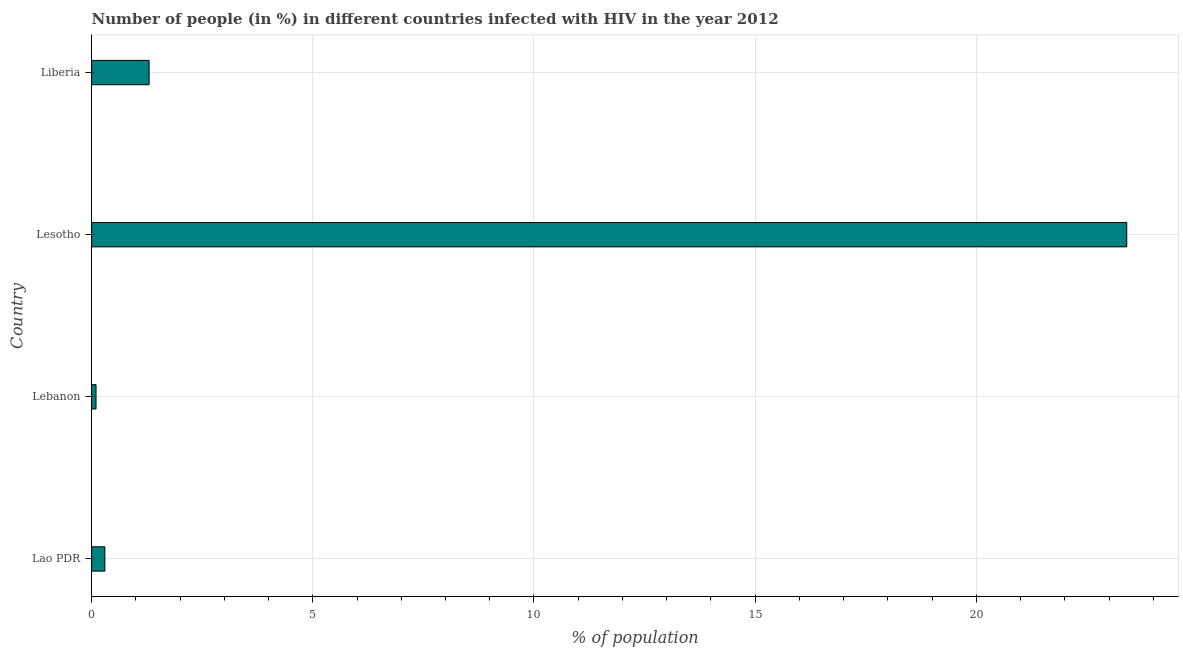Does the graph contain grids?
Make the answer very short. Yes. What is the title of the graph?
Offer a very short reply. Number of people (in %) in different countries infected with HIV in the year 2012. What is the label or title of the X-axis?
Offer a very short reply. % of population. What is the number of people infected with hiv in Lebanon?
Give a very brief answer. 0.1. Across all countries, what is the maximum number of people infected with hiv?
Keep it short and to the point. 23.4. In which country was the number of people infected with hiv maximum?
Your answer should be very brief. Lesotho. In which country was the number of people infected with hiv minimum?
Ensure brevity in your answer.  Lebanon. What is the sum of the number of people infected with hiv?
Offer a very short reply. 25.1. What is the difference between the number of people infected with hiv in Lao PDR and Lebanon?
Provide a succinct answer. 0.2. What is the average number of people infected with hiv per country?
Offer a terse response. 6.28. What is the median number of people infected with hiv?
Provide a succinct answer. 0.8. In how many countries, is the number of people infected with hiv greater than 20 %?
Provide a short and direct response. 1. What is the ratio of the number of people infected with hiv in Lao PDR to that in Liberia?
Give a very brief answer. 0.23. Is the difference between the number of people infected with hiv in Lao PDR and Lebanon greater than the difference between any two countries?
Your answer should be very brief. No. What is the difference between the highest and the second highest number of people infected with hiv?
Provide a short and direct response. 22.1. Is the sum of the number of people infected with hiv in Lesotho and Liberia greater than the maximum number of people infected with hiv across all countries?
Keep it short and to the point. Yes. What is the difference between the highest and the lowest number of people infected with hiv?
Offer a terse response. 23.3. How many bars are there?
Offer a very short reply. 4. What is the % of population of Lesotho?
Provide a succinct answer. 23.4. What is the % of population of Liberia?
Offer a terse response. 1.3. What is the difference between the % of population in Lao PDR and Lebanon?
Your answer should be very brief. 0.2. What is the difference between the % of population in Lao PDR and Lesotho?
Your response must be concise. -23.1. What is the difference between the % of population in Lao PDR and Liberia?
Keep it short and to the point. -1. What is the difference between the % of population in Lebanon and Lesotho?
Your answer should be compact. -23.3. What is the difference between the % of population in Lesotho and Liberia?
Your answer should be compact. 22.1. What is the ratio of the % of population in Lao PDR to that in Lebanon?
Provide a succinct answer. 3. What is the ratio of the % of population in Lao PDR to that in Lesotho?
Your answer should be compact. 0.01. What is the ratio of the % of population in Lao PDR to that in Liberia?
Your answer should be compact. 0.23. What is the ratio of the % of population in Lebanon to that in Lesotho?
Your response must be concise. 0. What is the ratio of the % of population in Lebanon to that in Liberia?
Your response must be concise. 0.08. What is the ratio of the % of population in Lesotho to that in Liberia?
Ensure brevity in your answer.  18. 